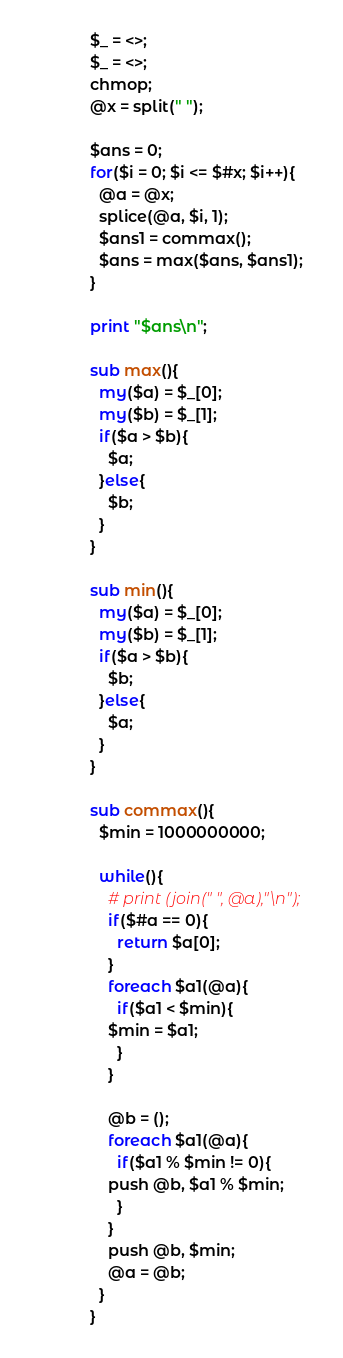Convert code to text. <code><loc_0><loc_0><loc_500><loc_500><_Perl_>$_ = <>;
$_ = <>;
chmop;
@x = split(" ");

$ans = 0;
for($i = 0; $i <= $#x; $i++){
  @a = @x;
  splice(@a, $i, 1);
  $ans1 = commax();
  $ans = max($ans, $ans1);
}

print "$ans\n";

sub max(){
  my($a) = $_[0];
  my($b) = $_[1];
  if($a > $b){
    $a;
  }else{
    $b;
  }
}

sub min(){
  my($a) = $_[0];
  my($b) = $_[1];
  if($a > $b){
    $b;
  }else{
    $a;
  }
}

sub commax(){
  $min = 1000000000;

  while(){
    # print (join(" ", @a),"\n");
    if($#a == 0){
      return $a[0];
    }
    foreach $a1(@a){
      if($a1 < $min){
	$min = $a1;
      }
    }

    @b = ();
    foreach $a1(@a){
      if($a1 % $min != 0){
	push @b, $a1 % $min;
      }
    }
    push @b, $min;
    @a = @b;
  }
}
</code> 